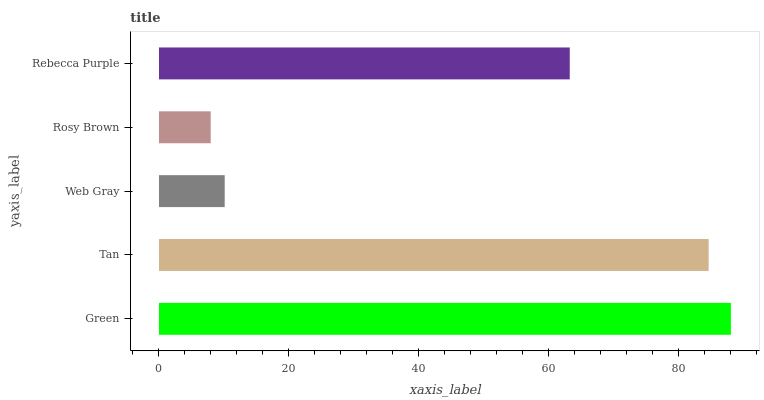Is Rosy Brown the minimum?
Answer yes or no. Yes. Is Green the maximum?
Answer yes or no. Yes. Is Tan the minimum?
Answer yes or no. No. Is Tan the maximum?
Answer yes or no. No. Is Green greater than Tan?
Answer yes or no. Yes. Is Tan less than Green?
Answer yes or no. Yes. Is Tan greater than Green?
Answer yes or no. No. Is Green less than Tan?
Answer yes or no. No. Is Rebecca Purple the high median?
Answer yes or no. Yes. Is Rebecca Purple the low median?
Answer yes or no. Yes. Is Tan the high median?
Answer yes or no. No. Is Rosy Brown the low median?
Answer yes or no. No. 